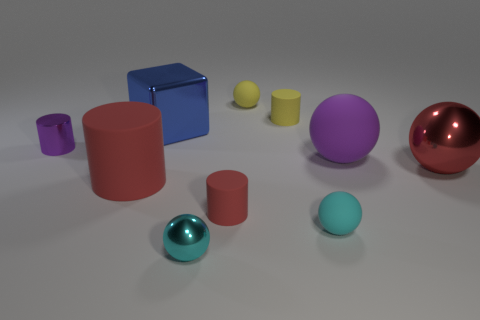Subtract all metal cylinders. How many cylinders are left? 3 Subtract all purple cubes. How many red cylinders are left? 2 Subtract all purple cylinders. How many cylinders are left? 3 Subtract 2 balls. How many balls are left? 3 Subtract all red balls. Subtract all brown cylinders. How many balls are left? 4 Subtract all big red matte objects. Subtract all large matte things. How many objects are left? 7 Add 6 red balls. How many red balls are left? 7 Add 9 small green metal cubes. How many small green metal cubes exist? 9 Subtract 1 yellow balls. How many objects are left? 9 Subtract all blocks. How many objects are left? 9 